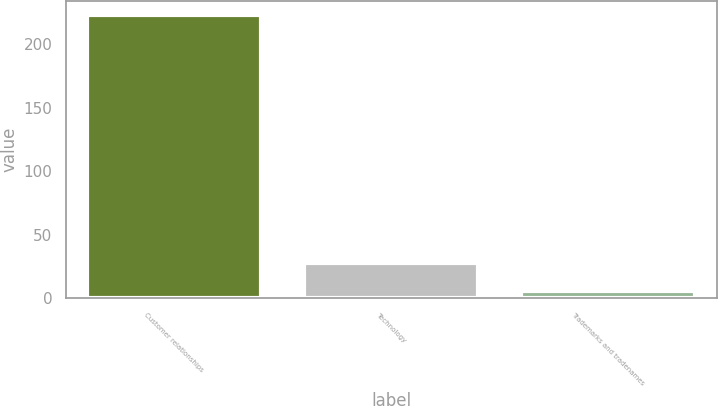<chart> <loc_0><loc_0><loc_500><loc_500><bar_chart><fcel>Customer relationships<fcel>Technology<fcel>Trademarks and tradenames<nl><fcel>222.9<fcel>27.69<fcel>6<nl></chart> 